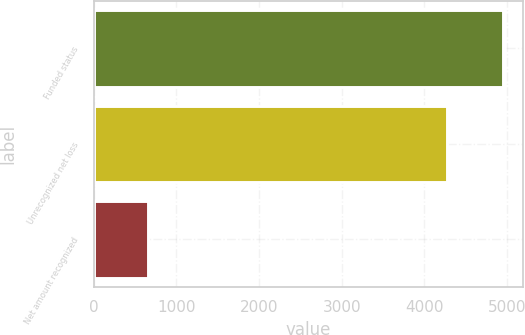Convert chart. <chart><loc_0><loc_0><loc_500><loc_500><bar_chart><fcel>Funded status<fcel>Unrecognized net loss<fcel>Net amount recognized<nl><fcel>4949<fcel>4272<fcel>650<nl></chart> 